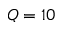Convert formula to latex. <formula><loc_0><loc_0><loc_500><loc_500>Q = 1 0</formula> 